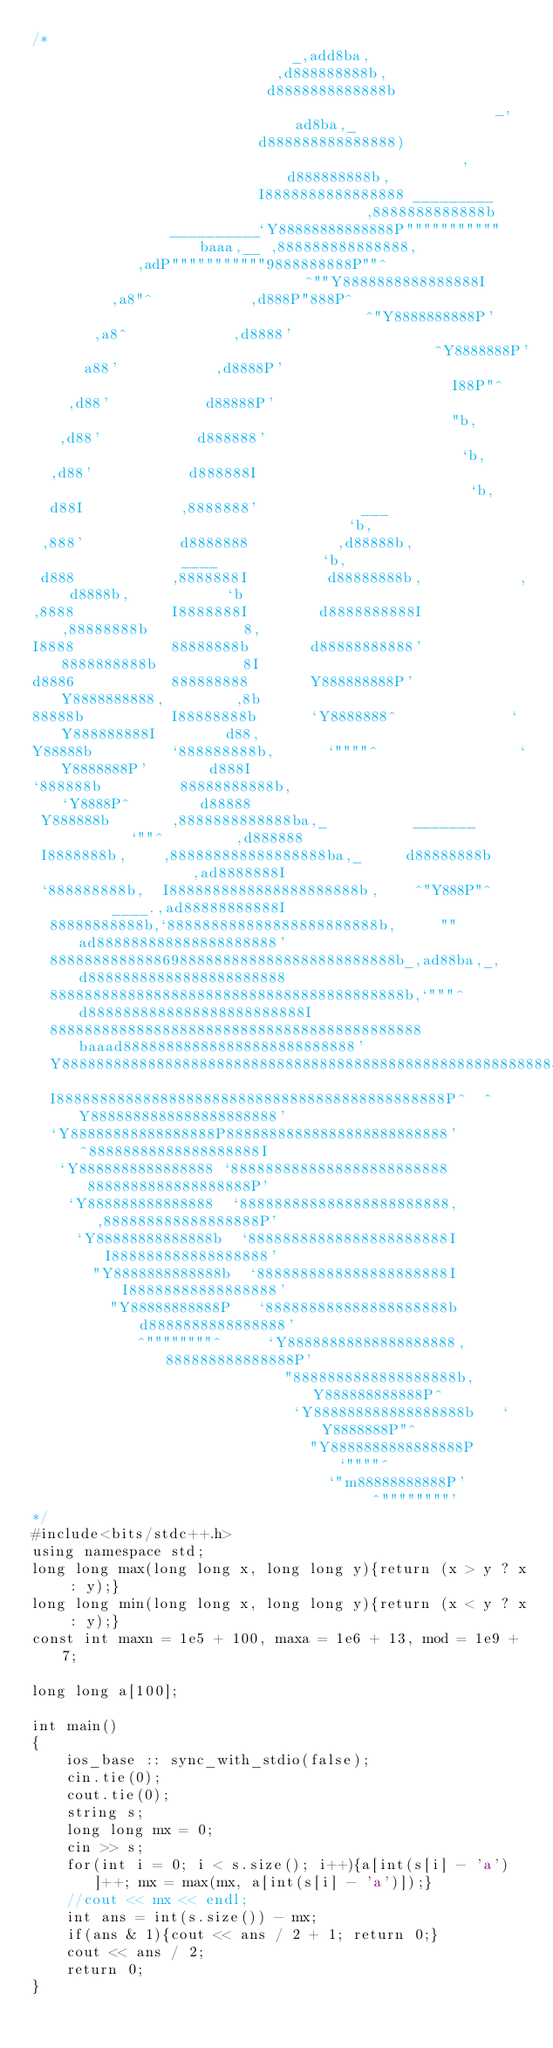Convert code to text. <code><loc_0><loc_0><loc_500><loc_500><_C++_>/*
                              _,add8ba,
                            ,d888888888b,
                           d8888888888888b                        _,ad8ba,_
                          d888888888888888)                     ,d888888888b,
                          I8888888888888888 _________          ,8888888888888b
                __________`Y88888888888888P"""""""""""baaa,__ ,888888888888888,
            ,adP"""""""""""9888888888P""^                 ^""Y8888888888888888I
         ,a8"^           ,d888P"888P^                           ^"Y8888888888P'
       ,a8^            ,d8888'                                     ^Y8888888P'
      a88'           ,d8888P'                                        I88P"^
    ,d88'           d88888P'                                          "b,
   ,d88'           d888888'                                            `b,
  ,d88'           d888888I                                              `b,
  d88I           ,8888888'            ___                                `b,
 ,888'           d8888888          ,d88888b,              ____            `b,
 d888           ,8888888I         d88888888b,           ,d8888b,           `b
,8888           I8888888I        d8888888888I          ,88888888b           8,
I8888           88888888b       d88888888888'          8888888888b          8I
d8886           888888888       Y888888888P'           Y8888888888,        ,8b
88888b          I88888888b      `Y8888888^             `Y888888888I        d88,
Y88888b         `888888888b,      `""""^                `Y8888888P'       d888I
`888888b         88888888888b,                           `Y8888P^        d88888
 Y888888b       ,8888888888888ba,_          _______        `""^        ,d888888
 I8888888b,    ,888888888888888888ba,_     d88888888b               ,ad8888888I
 `888888888b,  I8888888888888888888888b,    ^"Y888P"^      ____.,ad88888888888I
  88888888888b,`888888888888888888888888b,     ""      ad888888888888888888888'
  8888888888888698888888888888888888888888b_,ad88ba,_,d88888888888888888888888
  88888888888888888888888888888888888888888b,`"""^ d8888888888888888888888888I
  8888888888888888888888888888888888888888888baaad888888888888888888888888888'
  Y8888888888888888888888888888888888888888888888888888888888888888888888888P
  I888888888888888888888888888888888888888888888P^  ^Y8888888888888888888888'
  `Y88888888888888888P88888888888888888888888888'     ^88888888888888888888I
   `Y8888888888888888 `8888888888888888888888888       8888888888888888888P'
    `Y888888888888888  `888888888888888888888888,     ,888888888888888888P'
     `Y88888888888888b  `88888888888888888888888I     I888888888888888888'
       "Y8888888888888b  `8888888888888888888888I     I88888888888888888'
         "Y88888888888P   `888888888888888888888b     d8888888888888888'
            ^""""""""^     `Y88888888888888888888,    888888888888888P'
                             "8888888888888888888b,   Y888888888888P^
                              `Y888888888888888888b   `Y8888888P"^
                                "Y8888888888888888P     `""""^
                                  `"m88888888888P'
                                       ^""""""""'
*/
#include<bits/stdc++.h>
using namespace std;
long long max(long long x, long long y){return (x > y ? x : y);}
long long min(long long x, long long y){return (x < y ? x : y);}
const int maxn = 1e5 + 100, maxa = 1e6 + 13, mod = 1e9 + 7;

long long a[100];

int main()
{
    ios_base :: sync_with_stdio(false);
    cin.tie(0);
    cout.tie(0);
    string s;
    long long mx = 0;
    cin >> s;
    for(int i = 0; i < s.size(); i++){a[int(s[i] - 'a')]++; mx = max(mx, a[int(s[i] - 'a')]);}
    //cout << mx << endl;
    int ans = int(s.size()) - mx;
    if(ans & 1){cout << ans / 2 + 1; return 0;}
    cout << ans / 2;
    return 0;
}














</code> 